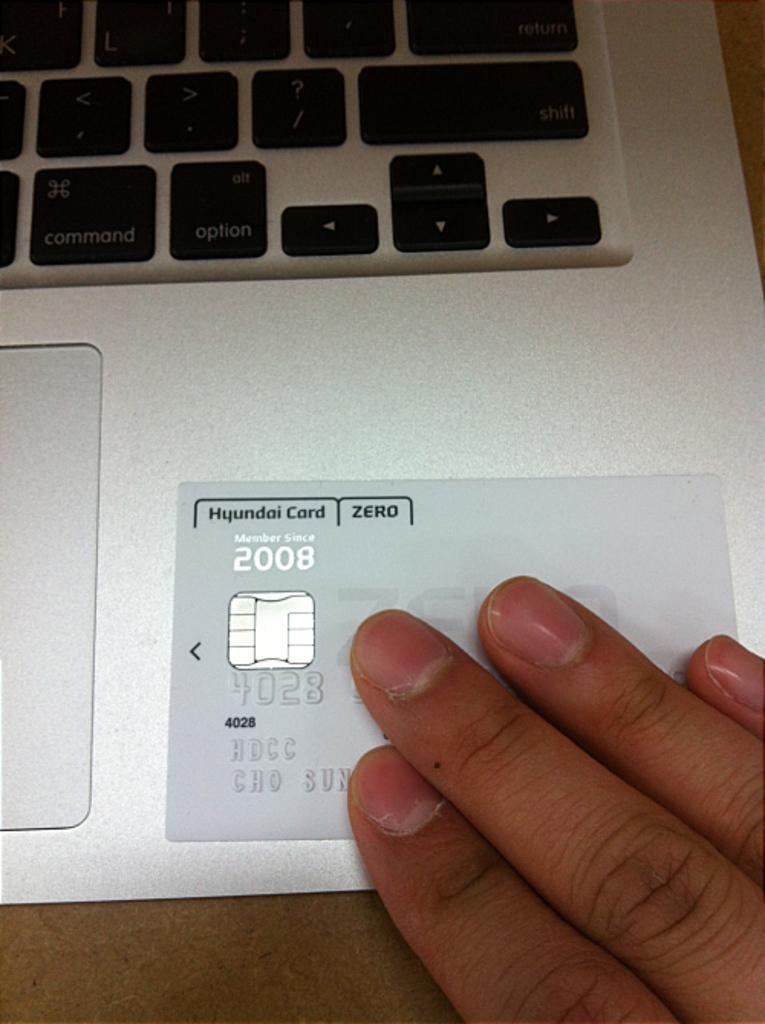What electronic device is present in the image? There is a laptop in the image. What is the color of the table on which the laptop is placed? The laptop is on a brown color table. Can you describe any interaction with the laptop in the image? A person's hand is visible on the laptop. What type of sock is the person wearing while using the laptop in the image? There is no information about the person's socks in the image, so it cannot be determined. 